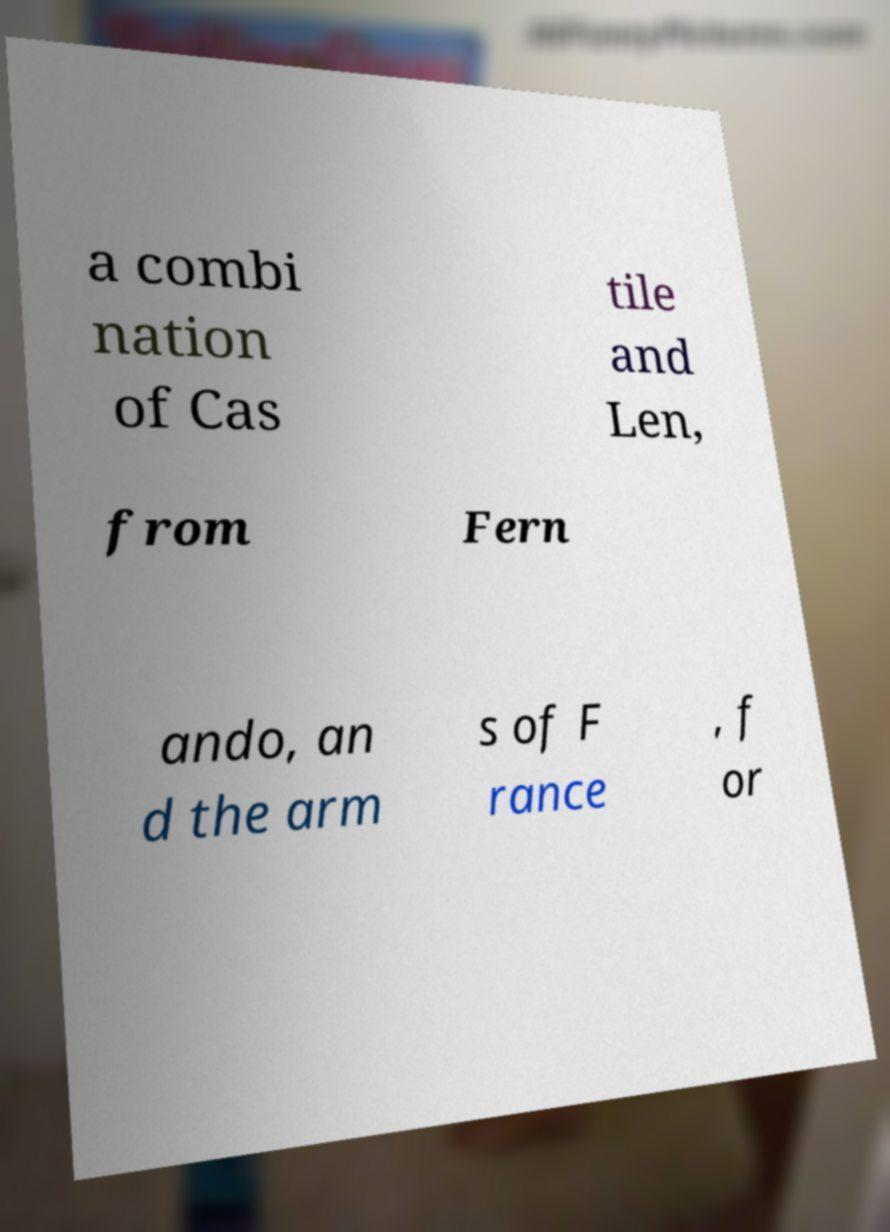Can you read and provide the text displayed in the image?This photo seems to have some interesting text. Can you extract and type it out for me? a combi nation of Cas tile and Len, from Fern ando, an d the arm s of F rance , f or 